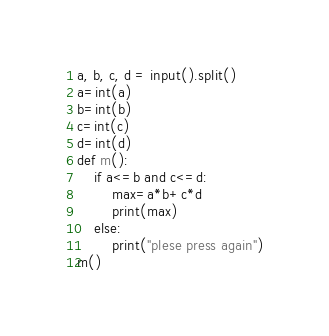<code> <loc_0><loc_0><loc_500><loc_500><_Python_>a, b, c, d = input().split()
a=int(a)
b=int(b)
c=int(c)
d=int(d)
def m():
    if a<=b and c<=d:
        max=a*b+c*d
        print(max)
    else:
        print("plese press again")
m()
</code> 